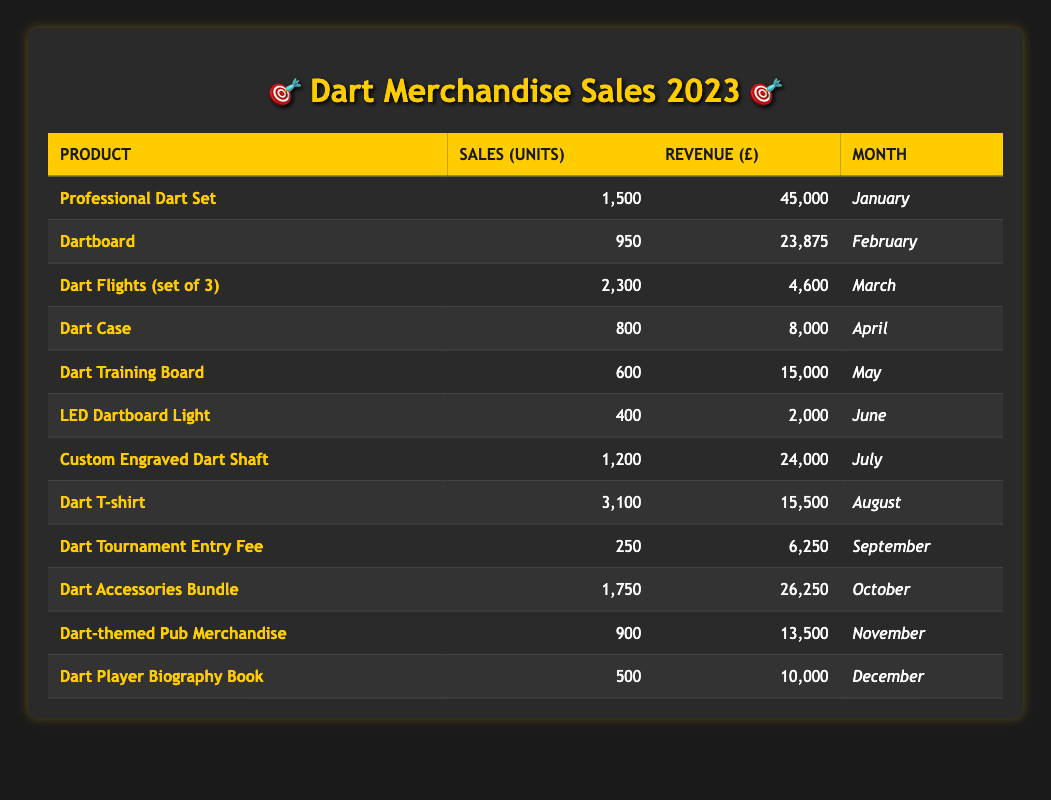What is the product with the highest sales in units in 2023? The table lists each product with its respective sales in units. By comparing all sales figures, the "Dart T-shirt" has the highest sales at 3,100 units.
Answer: Dart T-shirt What was the total revenue generated from all dart-themed merchandise in June? In June, the only product sold was the "LED Dartboard Light," which generated a revenue of 2,000 GBP. Therefore, the total revenue for June is simply that value.
Answer: 2,000 How many units of "Dart Flights (set of 3)" were sold compared to "Dart Training Board"? The "Dart Flights (set of 3)" sold 2,300 units, while the "Dart Training Board" sold 600 units. The difference is calculated as 2,300 - 600 = 1,700. Therefore, significantly more "Dart Flights" were sold.
Answer: 1,700 Did more than 1,000 units of the "Dart Accessories Bundle" sell in October? The "Dart Accessories Bundle" sold 1,750 units, which is greater than 1,000 units. Therefore, the statement is true.
Answer: Yes What product generated the most revenue in the first half of the year (January to June)? The products and their revenue in the first half are as follows: Professional Dart Set (45,000), Dartboard (23,875), Dart Flights (4,600), Dart Case (8,000), Dart Training Board (15,000), LED Dartboard Light (2,000). The highest revenue is from the "Professional Dart Set" with 45,000 GBP.
Answer: Professional Dart Set What is the average revenue of all products sold in 2023? To calculate the average revenue, sum all revenues: 45,000 + 23,875 + 4,600 + 8,000 + 15,000 + 2,000 + 24,000 + 15,500 + 6,250 + 26,250 + 13,500 + 10,000 =  162,475. With 12 products in total, the average is 162,475 / 12 = 13, návý 706.25.
Answer: 13,706.25 Did "Dart-themed Pub Merchandise" sell more units than "Dart Player Biography Book"? "Dart-themed Pub Merchandise" sold 900 units while the "Dart Player Biography Book" only sold 500 units. Since 900 is greater than 500, this statement is true.
Answer: Yes Which month had the lowest sales in units? The table shows sales by month. When reviewing all sales figures, "LED Dartboard Light" in June had the lowest sales at 400 units.
Answer: June 